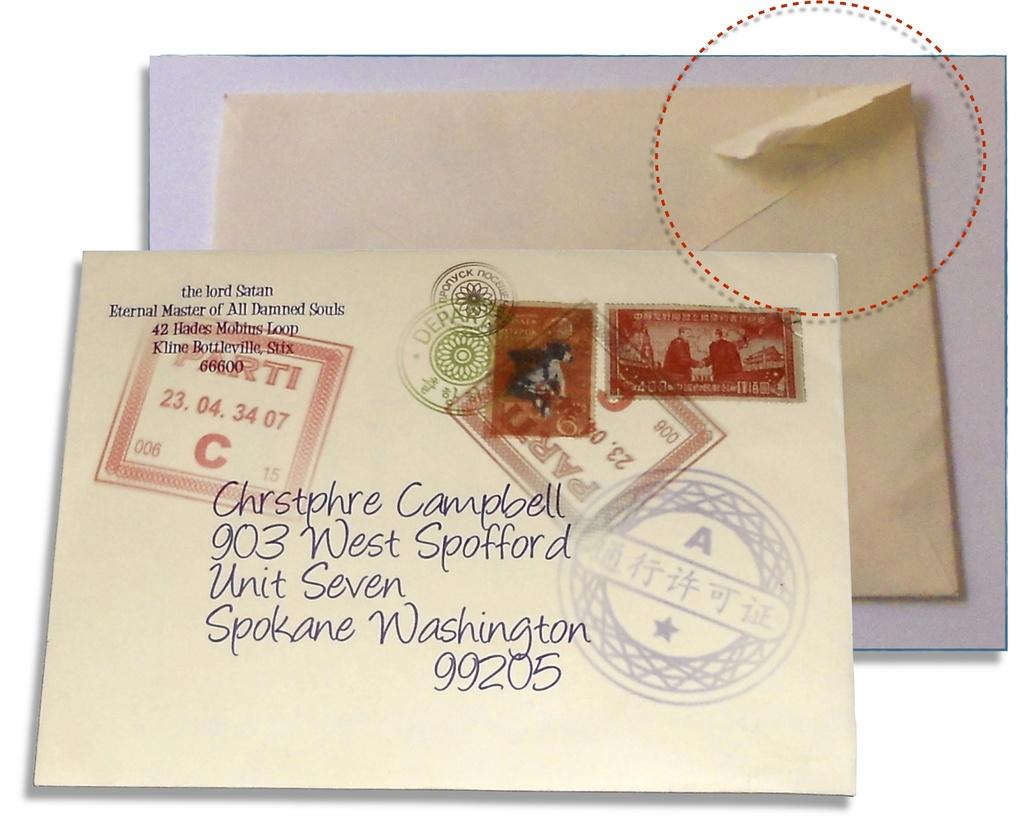<image>
Describe the image concisely. A letter is postmarked to someone in Spokane, Washington. 